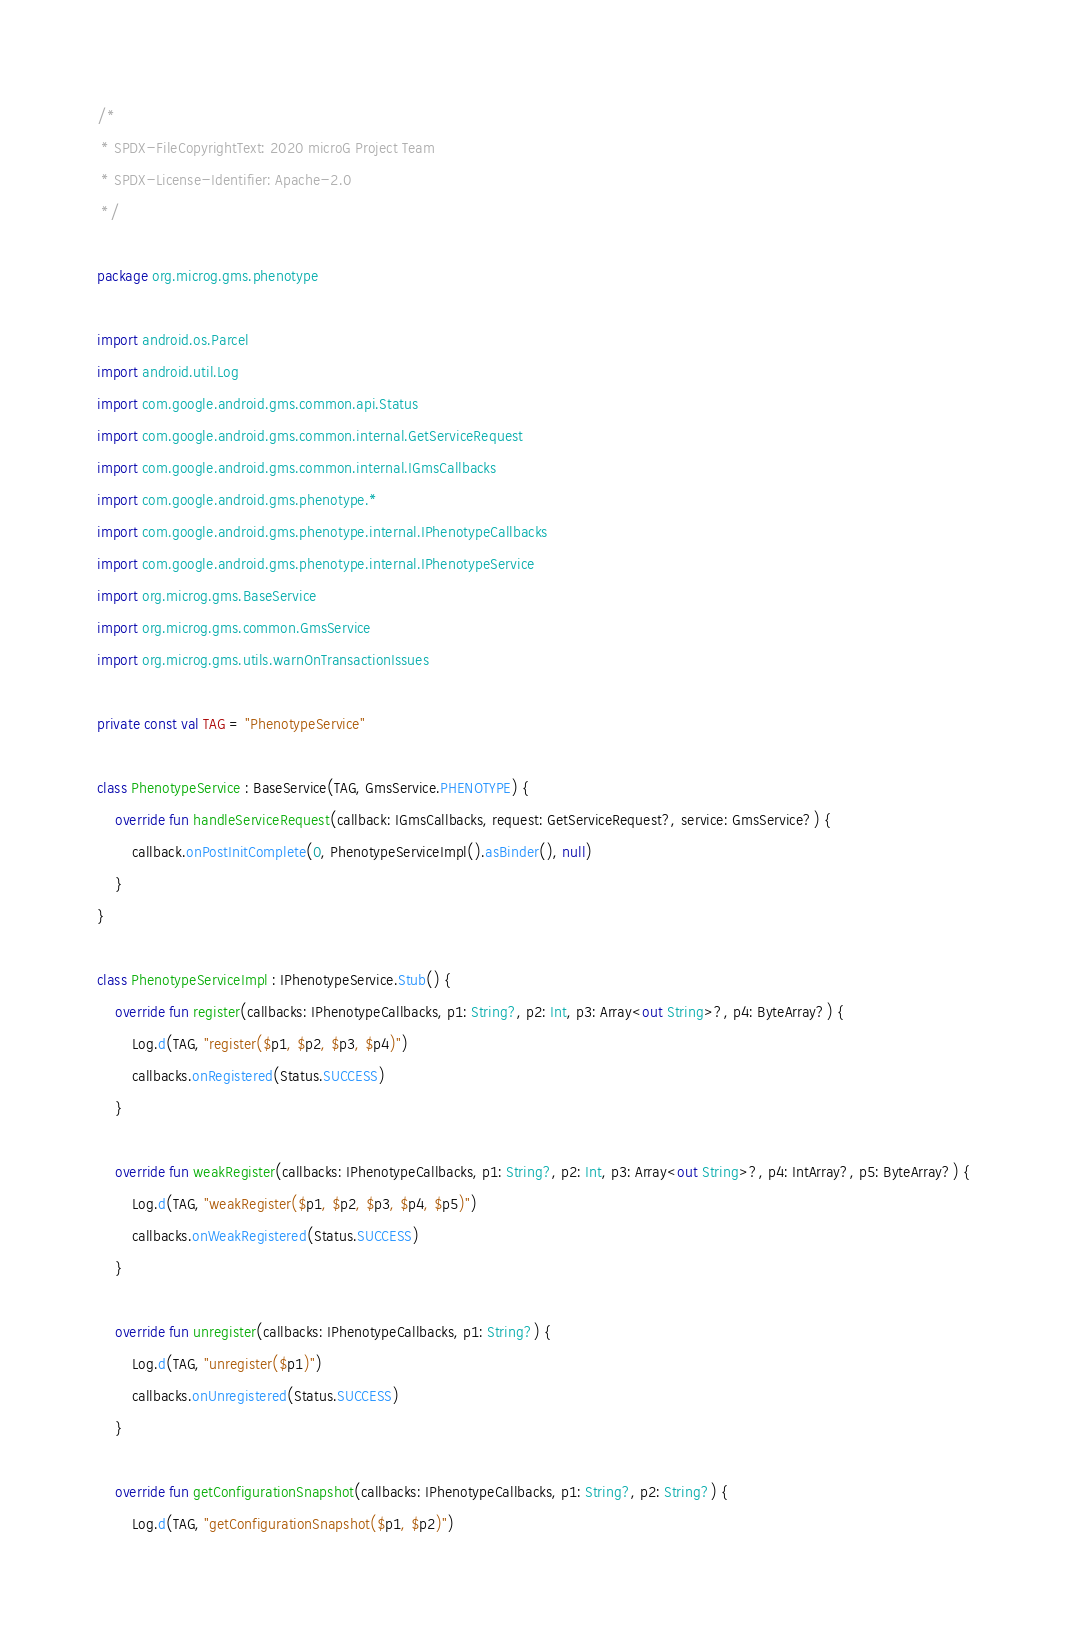Convert code to text. <code><loc_0><loc_0><loc_500><loc_500><_Kotlin_>/*
 * SPDX-FileCopyrightText: 2020 microG Project Team
 * SPDX-License-Identifier: Apache-2.0
 */

package org.microg.gms.phenotype

import android.os.Parcel
import android.util.Log
import com.google.android.gms.common.api.Status
import com.google.android.gms.common.internal.GetServiceRequest
import com.google.android.gms.common.internal.IGmsCallbacks
import com.google.android.gms.phenotype.*
import com.google.android.gms.phenotype.internal.IPhenotypeCallbacks
import com.google.android.gms.phenotype.internal.IPhenotypeService
import org.microg.gms.BaseService
import org.microg.gms.common.GmsService
import org.microg.gms.utils.warnOnTransactionIssues

private const val TAG = "PhenotypeService"

class PhenotypeService : BaseService(TAG, GmsService.PHENOTYPE) {
    override fun handleServiceRequest(callback: IGmsCallbacks, request: GetServiceRequest?, service: GmsService?) {
        callback.onPostInitComplete(0, PhenotypeServiceImpl().asBinder(), null)
    }
}

class PhenotypeServiceImpl : IPhenotypeService.Stub() {
    override fun register(callbacks: IPhenotypeCallbacks, p1: String?, p2: Int, p3: Array<out String>?, p4: ByteArray?) {
        Log.d(TAG, "register($p1, $p2, $p3, $p4)")
        callbacks.onRegistered(Status.SUCCESS)
    }

    override fun weakRegister(callbacks: IPhenotypeCallbacks, p1: String?, p2: Int, p3: Array<out String>?, p4: IntArray?, p5: ByteArray?) {
        Log.d(TAG, "weakRegister($p1, $p2, $p3, $p4, $p5)")
        callbacks.onWeakRegistered(Status.SUCCESS)
    }

    override fun unregister(callbacks: IPhenotypeCallbacks, p1: String?) {
        Log.d(TAG, "unregister($p1)")
        callbacks.onUnregistered(Status.SUCCESS)
    }

    override fun getConfigurationSnapshot(callbacks: IPhenotypeCallbacks, p1: String?, p2: String?) {
        Log.d(TAG, "getConfigurationSnapshot($p1, $p2)")</code> 